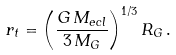Convert formula to latex. <formula><loc_0><loc_0><loc_500><loc_500>r _ { t } = \left ( \frac { G \, M _ { e c l } } { 3 \, M _ { G } } \right ) ^ { 1 / 3 } R _ { G } \, .</formula> 